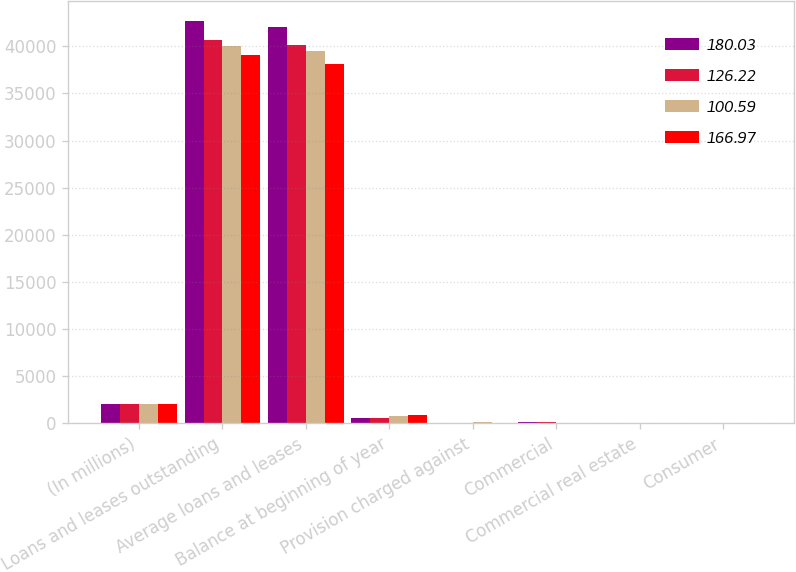Convert chart to OTSL. <chart><loc_0><loc_0><loc_500><loc_500><stacked_bar_chart><ecel><fcel>(In millions)<fcel>Loans and leases outstanding<fcel>Average loans and leases<fcel>Balance at beginning of year<fcel>Provision charged against<fcel>Commercial<fcel>Commercial real estate<fcel>Consumer<nl><fcel>180.03<fcel>2016<fcel>42649<fcel>42062<fcel>606<fcel>93<fcel>169<fcel>12<fcel>16<nl><fcel>126.22<fcel>2015<fcel>40650<fcel>40171<fcel>605<fcel>40<fcel>111<fcel>14<fcel>14<nl><fcel>100.59<fcel>2014<fcel>40064<fcel>39522<fcel>746<fcel>98<fcel>77<fcel>15<fcel>14<nl><fcel>166.97<fcel>2013<fcel>39043<fcel>38109<fcel>896<fcel>87<fcel>76<fcel>26<fcel>29<nl></chart> 